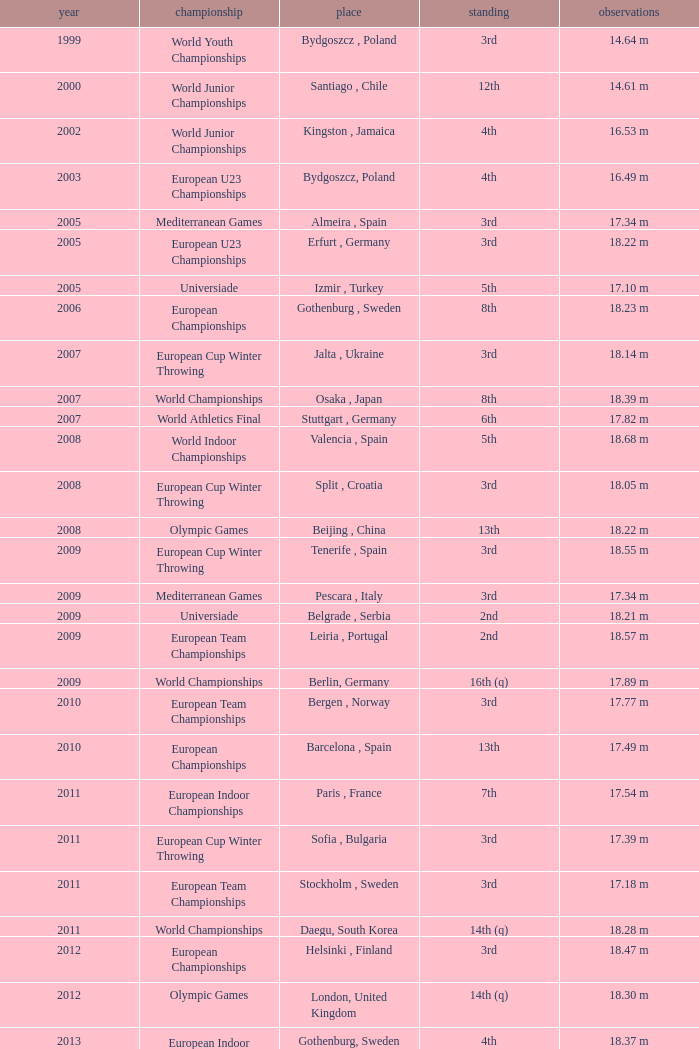What are the notes for bydgoszcz, Poland? 14.64 m, 16.49 m. Parse the table in full. {'header': ['year', 'championship', 'place', 'standing', 'observations'], 'rows': [['1999', 'World Youth Championships', 'Bydgoszcz , Poland', '3rd', '14.64 m'], ['2000', 'World Junior Championships', 'Santiago , Chile', '12th', '14.61 m'], ['2002', 'World Junior Championships', 'Kingston , Jamaica', '4th', '16.53 m'], ['2003', 'European U23 Championships', 'Bydgoszcz, Poland', '4th', '16.49 m'], ['2005', 'Mediterranean Games', 'Almeira , Spain', '3rd', '17.34 m'], ['2005', 'European U23 Championships', 'Erfurt , Germany', '3rd', '18.22 m'], ['2005', 'Universiade', 'Izmir , Turkey', '5th', '17.10 m'], ['2006', 'European Championships', 'Gothenburg , Sweden', '8th', '18.23 m'], ['2007', 'European Cup Winter Throwing', 'Jalta , Ukraine', '3rd', '18.14 m'], ['2007', 'World Championships', 'Osaka , Japan', '8th', '18.39 m'], ['2007', 'World Athletics Final', 'Stuttgart , Germany', '6th', '17.82 m'], ['2008', 'World Indoor Championships', 'Valencia , Spain', '5th', '18.68 m'], ['2008', 'European Cup Winter Throwing', 'Split , Croatia', '3rd', '18.05 m'], ['2008', 'Olympic Games', 'Beijing , China', '13th', '18.22 m'], ['2009', 'European Cup Winter Throwing', 'Tenerife , Spain', '3rd', '18.55 m'], ['2009', 'Mediterranean Games', 'Pescara , Italy', '3rd', '17.34 m'], ['2009', 'Universiade', 'Belgrade , Serbia', '2nd', '18.21 m'], ['2009', 'European Team Championships', 'Leiria , Portugal', '2nd', '18.57 m'], ['2009', 'World Championships', 'Berlin, Germany', '16th (q)', '17.89 m'], ['2010', 'European Team Championships', 'Bergen , Norway', '3rd', '17.77 m'], ['2010', 'European Championships', 'Barcelona , Spain', '13th', '17.49 m'], ['2011', 'European Indoor Championships', 'Paris , France', '7th', '17.54 m'], ['2011', 'European Cup Winter Throwing', 'Sofia , Bulgaria', '3rd', '17.39 m'], ['2011', 'European Team Championships', 'Stockholm , Sweden', '3rd', '17.18 m'], ['2011', 'World Championships', 'Daegu, South Korea', '14th (q)', '18.28 m'], ['2012', 'European Championships', 'Helsinki , Finland', '3rd', '18.47 m'], ['2012', 'Olympic Games', 'London, United Kingdom', '14th (q)', '18.30 m'], ['2013', 'European Indoor Championships', 'Gothenburg, Sweden', '4th', '18.37 m'], ['2013', 'World Championships', 'Moscow, Russia', '22nd (q)', '17.18 m']]} 